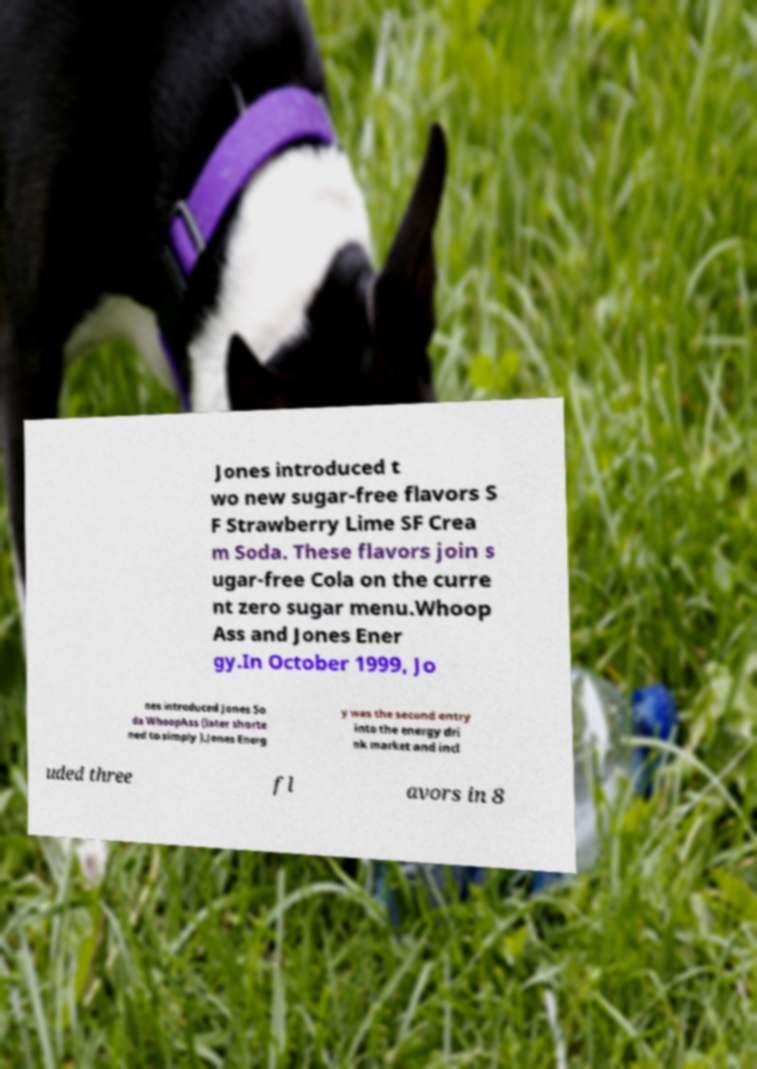Please read and relay the text visible in this image. What does it say? Jones introduced t wo new sugar-free flavors S F Strawberry Lime SF Crea m Soda. These flavors join s ugar-free Cola on the curre nt zero sugar menu.Whoop Ass and Jones Ener gy.In October 1999, Jo nes introduced Jones So da WhoopAss (later shorte ned to simply ).Jones Energ y was the second entry into the energy dri nk market and incl uded three fl avors in 8 